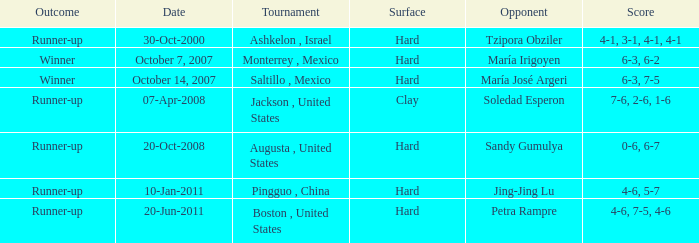What contest occurred on the date of october 14, 2007? Saltillo , Mexico. 